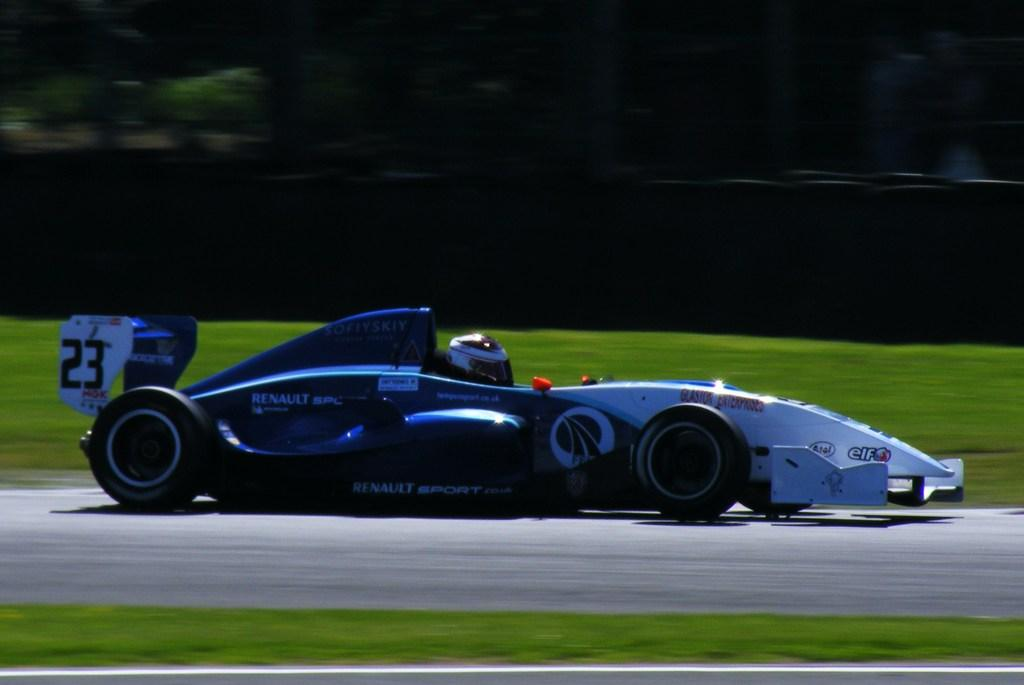What is the main subject of the image? There is a car on the road in the image. What type of vegetation can be seen in the image? There is grass visible in the image. What safety gear is present in the image? A helmet is present in the image. How would you describe the background of the image? The background of the image is blurry. How many babies are crawling on the grass in the image? There are no babies present in the image; it features a car on the road and a blurry background. What is the car looking at in the image? Cars do not have the ability to look, as they are inanimate objects. 